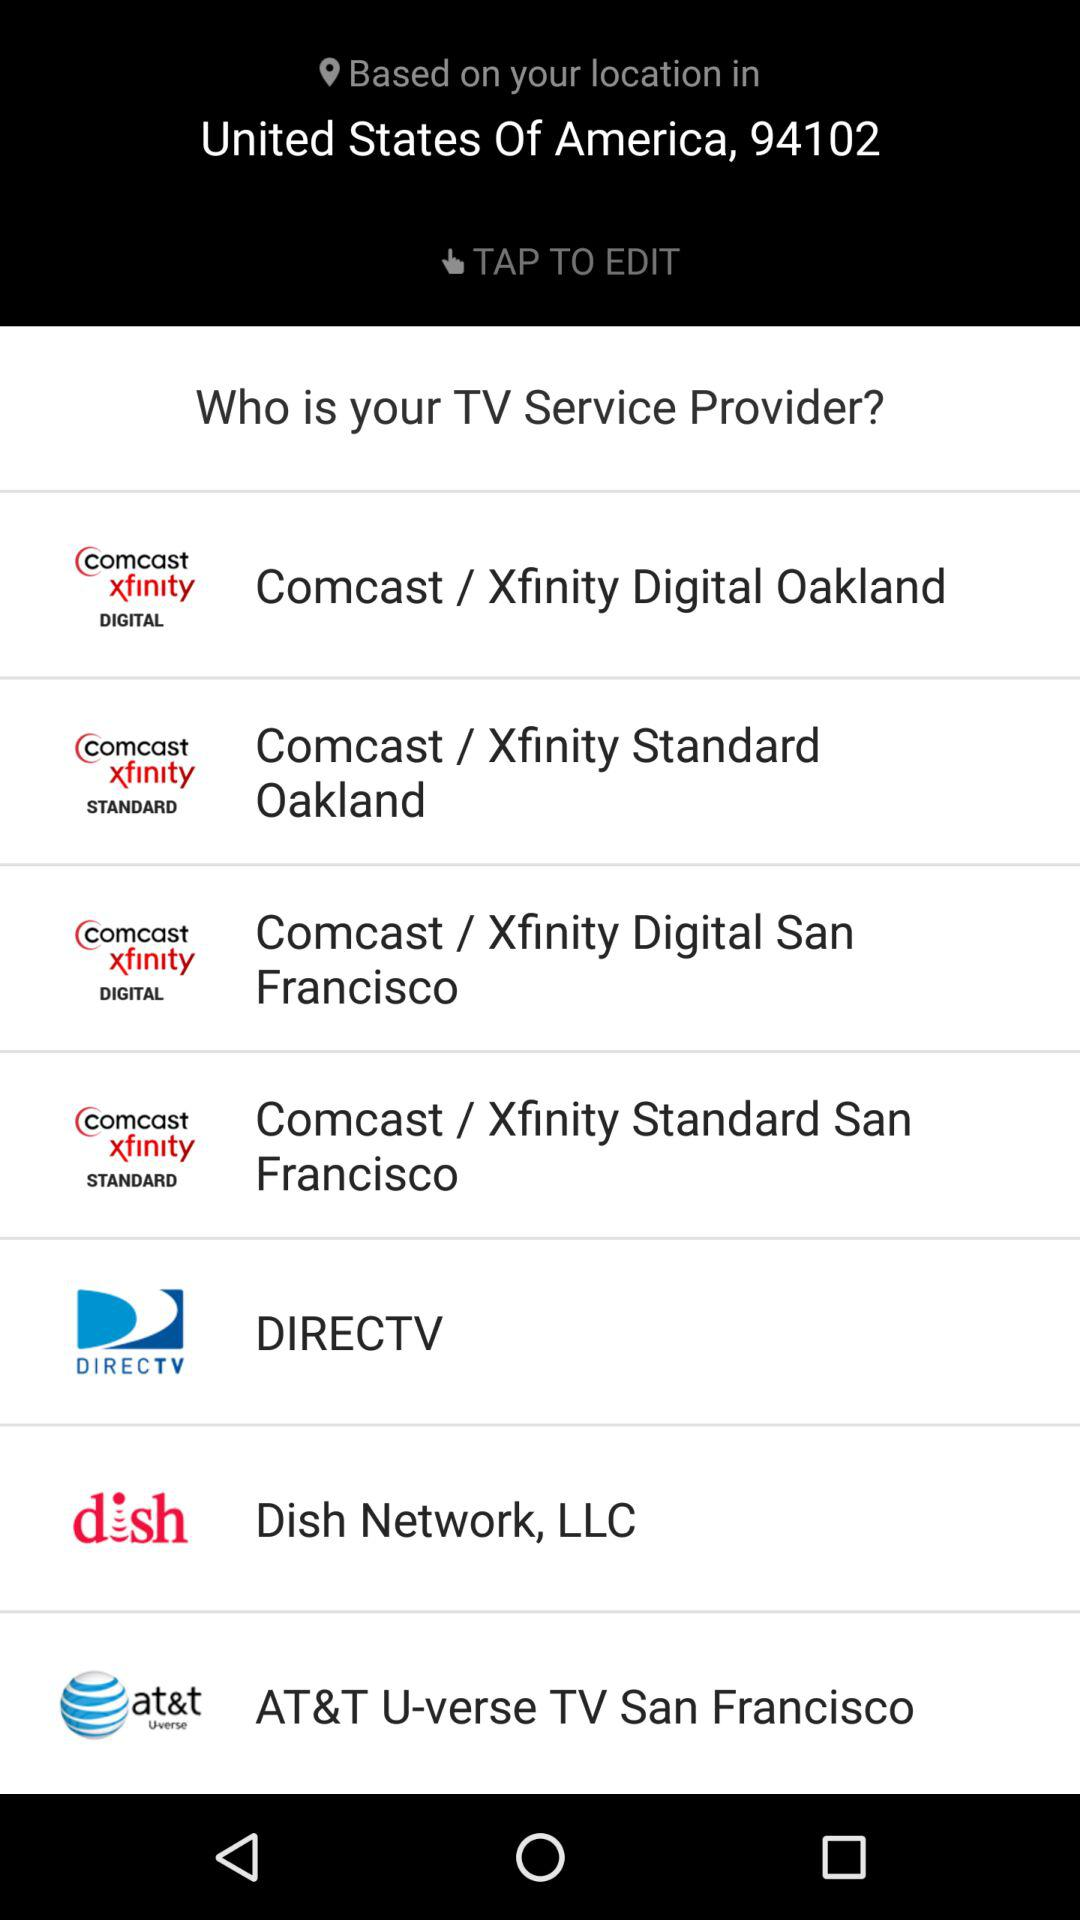What is the mentioned location? The mentioned location is the United States of America, 94102. 